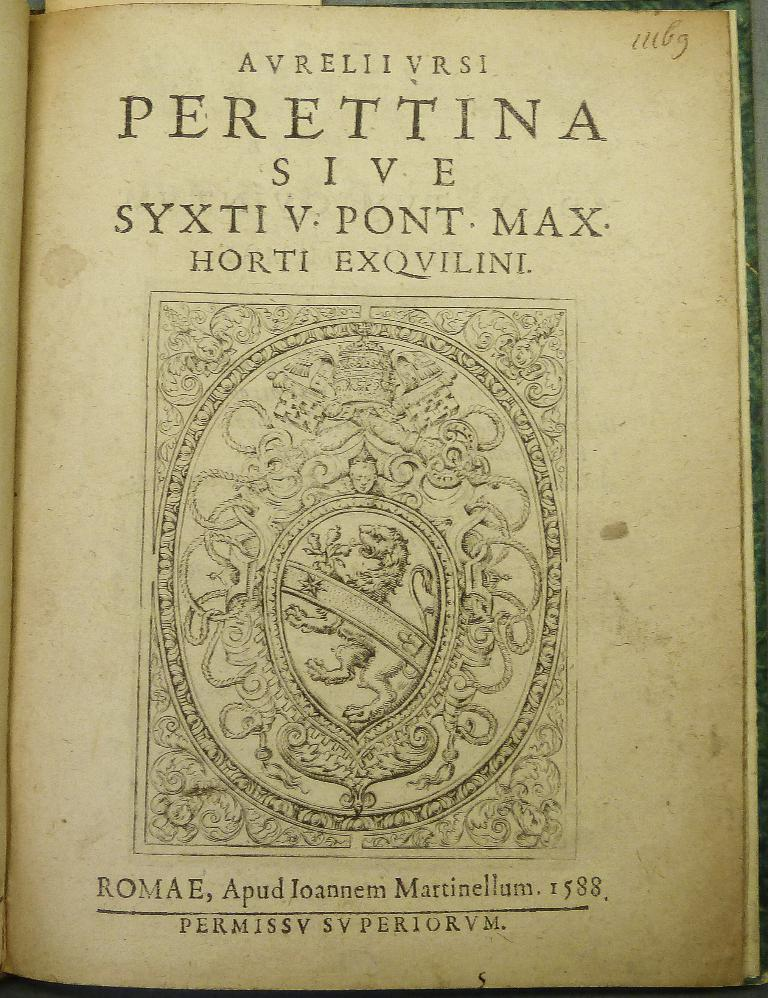<image>
Share a concise interpretation of the image provided. A very old book is open to a page that begins with the word AVRELIIVRSI. 